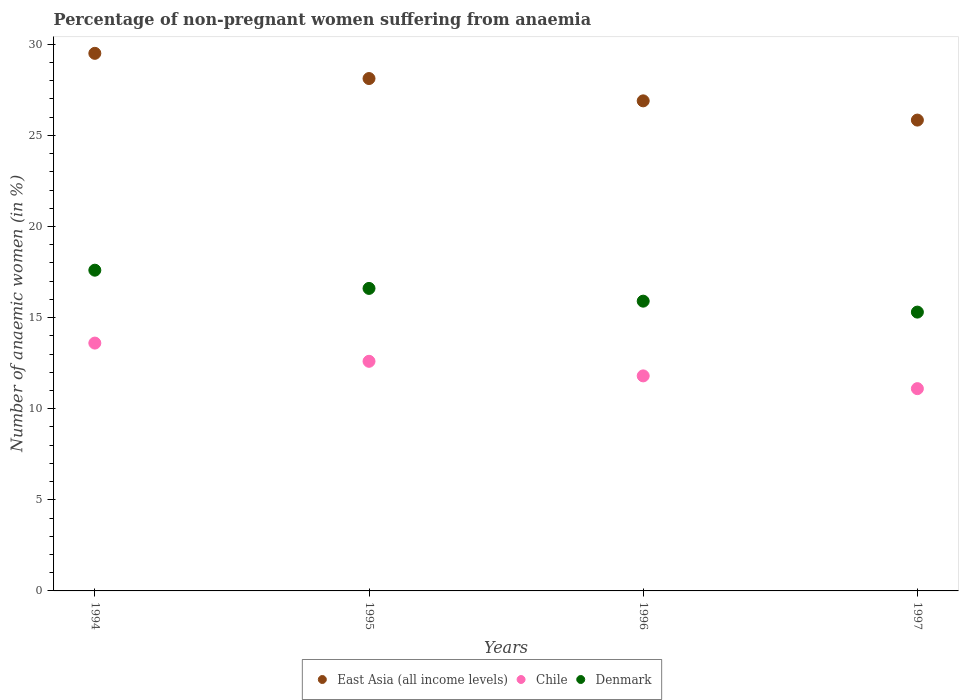How many different coloured dotlines are there?
Offer a very short reply. 3. Is the number of dotlines equal to the number of legend labels?
Ensure brevity in your answer.  Yes. What is the percentage of non-pregnant women suffering from anaemia in East Asia (all income levels) in 1994?
Offer a terse response. 29.5. Across all years, what is the minimum percentage of non-pregnant women suffering from anaemia in Denmark?
Your response must be concise. 15.3. What is the total percentage of non-pregnant women suffering from anaemia in Denmark in the graph?
Make the answer very short. 65.4. What is the difference between the percentage of non-pregnant women suffering from anaemia in East Asia (all income levels) in 1996 and that in 1997?
Keep it short and to the point. 1.06. What is the difference between the percentage of non-pregnant women suffering from anaemia in East Asia (all income levels) in 1994 and the percentage of non-pregnant women suffering from anaemia in Denmark in 1996?
Your response must be concise. 13.6. What is the average percentage of non-pregnant women suffering from anaemia in Denmark per year?
Ensure brevity in your answer.  16.35. In the year 1996, what is the difference between the percentage of non-pregnant women suffering from anaemia in Chile and percentage of non-pregnant women suffering from anaemia in East Asia (all income levels)?
Your answer should be compact. -15.09. In how many years, is the percentage of non-pregnant women suffering from anaemia in East Asia (all income levels) greater than 3 %?
Offer a terse response. 4. What is the ratio of the percentage of non-pregnant women suffering from anaemia in East Asia (all income levels) in 1996 to that in 1997?
Your response must be concise. 1.04. Is the difference between the percentage of non-pregnant women suffering from anaemia in Chile in 1994 and 1995 greater than the difference between the percentage of non-pregnant women suffering from anaemia in East Asia (all income levels) in 1994 and 1995?
Provide a succinct answer. No. Is it the case that in every year, the sum of the percentage of non-pregnant women suffering from anaemia in Denmark and percentage of non-pregnant women suffering from anaemia in Chile  is greater than the percentage of non-pregnant women suffering from anaemia in East Asia (all income levels)?
Keep it short and to the point. Yes. Does the percentage of non-pregnant women suffering from anaemia in Denmark monotonically increase over the years?
Offer a very short reply. No. Is the percentage of non-pregnant women suffering from anaemia in Denmark strictly greater than the percentage of non-pregnant women suffering from anaemia in Chile over the years?
Give a very brief answer. Yes. How many dotlines are there?
Your answer should be very brief. 3. What is the difference between two consecutive major ticks on the Y-axis?
Provide a succinct answer. 5. Does the graph contain grids?
Make the answer very short. No. Where does the legend appear in the graph?
Your answer should be very brief. Bottom center. How are the legend labels stacked?
Your response must be concise. Horizontal. What is the title of the graph?
Provide a short and direct response. Percentage of non-pregnant women suffering from anaemia. What is the label or title of the X-axis?
Keep it short and to the point. Years. What is the label or title of the Y-axis?
Provide a succinct answer. Number of anaemic women (in %). What is the Number of anaemic women (in %) of East Asia (all income levels) in 1994?
Make the answer very short. 29.5. What is the Number of anaemic women (in %) of Chile in 1994?
Give a very brief answer. 13.6. What is the Number of anaemic women (in %) of Denmark in 1994?
Offer a very short reply. 17.6. What is the Number of anaemic women (in %) of East Asia (all income levels) in 1995?
Your response must be concise. 28.12. What is the Number of anaemic women (in %) of Chile in 1995?
Provide a succinct answer. 12.6. What is the Number of anaemic women (in %) in East Asia (all income levels) in 1996?
Provide a succinct answer. 26.89. What is the Number of anaemic women (in %) of Denmark in 1996?
Your answer should be compact. 15.9. What is the Number of anaemic women (in %) in East Asia (all income levels) in 1997?
Provide a succinct answer. 25.84. What is the Number of anaemic women (in %) of Denmark in 1997?
Provide a short and direct response. 15.3. Across all years, what is the maximum Number of anaemic women (in %) of East Asia (all income levels)?
Keep it short and to the point. 29.5. Across all years, what is the maximum Number of anaemic women (in %) in Denmark?
Offer a very short reply. 17.6. Across all years, what is the minimum Number of anaemic women (in %) in East Asia (all income levels)?
Your response must be concise. 25.84. Across all years, what is the minimum Number of anaemic women (in %) in Denmark?
Offer a terse response. 15.3. What is the total Number of anaemic women (in %) in East Asia (all income levels) in the graph?
Your response must be concise. 110.35. What is the total Number of anaemic women (in %) of Chile in the graph?
Keep it short and to the point. 49.1. What is the total Number of anaemic women (in %) in Denmark in the graph?
Offer a terse response. 65.4. What is the difference between the Number of anaemic women (in %) of East Asia (all income levels) in 1994 and that in 1995?
Keep it short and to the point. 1.38. What is the difference between the Number of anaemic women (in %) in Chile in 1994 and that in 1995?
Your answer should be compact. 1. What is the difference between the Number of anaemic women (in %) of East Asia (all income levels) in 1994 and that in 1996?
Provide a succinct answer. 2.61. What is the difference between the Number of anaemic women (in %) in Denmark in 1994 and that in 1996?
Offer a terse response. 1.7. What is the difference between the Number of anaemic women (in %) of East Asia (all income levels) in 1994 and that in 1997?
Make the answer very short. 3.66. What is the difference between the Number of anaemic women (in %) in East Asia (all income levels) in 1995 and that in 1996?
Your response must be concise. 1.22. What is the difference between the Number of anaemic women (in %) in Chile in 1995 and that in 1996?
Provide a short and direct response. 0.8. What is the difference between the Number of anaemic women (in %) of East Asia (all income levels) in 1995 and that in 1997?
Offer a terse response. 2.28. What is the difference between the Number of anaemic women (in %) of East Asia (all income levels) in 1996 and that in 1997?
Give a very brief answer. 1.06. What is the difference between the Number of anaemic women (in %) of Denmark in 1996 and that in 1997?
Provide a short and direct response. 0.6. What is the difference between the Number of anaemic women (in %) in East Asia (all income levels) in 1994 and the Number of anaemic women (in %) in Chile in 1995?
Keep it short and to the point. 16.9. What is the difference between the Number of anaemic women (in %) of East Asia (all income levels) in 1994 and the Number of anaemic women (in %) of Denmark in 1995?
Provide a succinct answer. 12.9. What is the difference between the Number of anaemic women (in %) of Chile in 1994 and the Number of anaemic women (in %) of Denmark in 1995?
Offer a very short reply. -3. What is the difference between the Number of anaemic women (in %) of East Asia (all income levels) in 1994 and the Number of anaemic women (in %) of Chile in 1996?
Offer a terse response. 17.7. What is the difference between the Number of anaemic women (in %) of East Asia (all income levels) in 1994 and the Number of anaemic women (in %) of Denmark in 1996?
Provide a succinct answer. 13.6. What is the difference between the Number of anaemic women (in %) in East Asia (all income levels) in 1994 and the Number of anaemic women (in %) in Chile in 1997?
Offer a very short reply. 18.4. What is the difference between the Number of anaemic women (in %) in East Asia (all income levels) in 1994 and the Number of anaemic women (in %) in Denmark in 1997?
Make the answer very short. 14.2. What is the difference between the Number of anaemic women (in %) in East Asia (all income levels) in 1995 and the Number of anaemic women (in %) in Chile in 1996?
Give a very brief answer. 16.32. What is the difference between the Number of anaemic women (in %) of East Asia (all income levels) in 1995 and the Number of anaemic women (in %) of Denmark in 1996?
Provide a succinct answer. 12.22. What is the difference between the Number of anaemic women (in %) in Chile in 1995 and the Number of anaemic women (in %) in Denmark in 1996?
Offer a terse response. -3.3. What is the difference between the Number of anaemic women (in %) in East Asia (all income levels) in 1995 and the Number of anaemic women (in %) in Chile in 1997?
Your answer should be very brief. 17.02. What is the difference between the Number of anaemic women (in %) in East Asia (all income levels) in 1995 and the Number of anaemic women (in %) in Denmark in 1997?
Offer a terse response. 12.82. What is the difference between the Number of anaemic women (in %) of Chile in 1995 and the Number of anaemic women (in %) of Denmark in 1997?
Ensure brevity in your answer.  -2.7. What is the difference between the Number of anaemic women (in %) of East Asia (all income levels) in 1996 and the Number of anaemic women (in %) of Chile in 1997?
Make the answer very short. 15.79. What is the difference between the Number of anaemic women (in %) in East Asia (all income levels) in 1996 and the Number of anaemic women (in %) in Denmark in 1997?
Provide a succinct answer. 11.59. What is the average Number of anaemic women (in %) in East Asia (all income levels) per year?
Provide a short and direct response. 27.59. What is the average Number of anaemic women (in %) of Chile per year?
Provide a succinct answer. 12.28. What is the average Number of anaemic women (in %) of Denmark per year?
Provide a succinct answer. 16.35. In the year 1994, what is the difference between the Number of anaemic women (in %) in East Asia (all income levels) and Number of anaemic women (in %) in Chile?
Provide a succinct answer. 15.9. In the year 1994, what is the difference between the Number of anaemic women (in %) of East Asia (all income levels) and Number of anaemic women (in %) of Denmark?
Provide a short and direct response. 11.9. In the year 1994, what is the difference between the Number of anaemic women (in %) of Chile and Number of anaemic women (in %) of Denmark?
Ensure brevity in your answer.  -4. In the year 1995, what is the difference between the Number of anaemic women (in %) of East Asia (all income levels) and Number of anaemic women (in %) of Chile?
Make the answer very short. 15.52. In the year 1995, what is the difference between the Number of anaemic women (in %) in East Asia (all income levels) and Number of anaemic women (in %) in Denmark?
Offer a terse response. 11.52. In the year 1995, what is the difference between the Number of anaemic women (in %) of Chile and Number of anaemic women (in %) of Denmark?
Provide a succinct answer. -4. In the year 1996, what is the difference between the Number of anaemic women (in %) of East Asia (all income levels) and Number of anaemic women (in %) of Chile?
Offer a terse response. 15.09. In the year 1996, what is the difference between the Number of anaemic women (in %) of East Asia (all income levels) and Number of anaemic women (in %) of Denmark?
Your answer should be very brief. 10.99. In the year 1996, what is the difference between the Number of anaemic women (in %) in Chile and Number of anaemic women (in %) in Denmark?
Your answer should be very brief. -4.1. In the year 1997, what is the difference between the Number of anaemic women (in %) in East Asia (all income levels) and Number of anaemic women (in %) in Chile?
Ensure brevity in your answer.  14.74. In the year 1997, what is the difference between the Number of anaemic women (in %) in East Asia (all income levels) and Number of anaemic women (in %) in Denmark?
Ensure brevity in your answer.  10.54. In the year 1997, what is the difference between the Number of anaemic women (in %) of Chile and Number of anaemic women (in %) of Denmark?
Make the answer very short. -4.2. What is the ratio of the Number of anaemic women (in %) in East Asia (all income levels) in 1994 to that in 1995?
Offer a terse response. 1.05. What is the ratio of the Number of anaemic women (in %) in Chile in 1994 to that in 1995?
Keep it short and to the point. 1.08. What is the ratio of the Number of anaemic women (in %) of Denmark in 1994 to that in 1995?
Provide a short and direct response. 1.06. What is the ratio of the Number of anaemic women (in %) of East Asia (all income levels) in 1994 to that in 1996?
Provide a short and direct response. 1.1. What is the ratio of the Number of anaemic women (in %) in Chile in 1994 to that in 1996?
Offer a very short reply. 1.15. What is the ratio of the Number of anaemic women (in %) of Denmark in 1994 to that in 1996?
Offer a terse response. 1.11. What is the ratio of the Number of anaemic women (in %) in East Asia (all income levels) in 1994 to that in 1997?
Provide a succinct answer. 1.14. What is the ratio of the Number of anaemic women (in %) in Chile in 1994 to that in 1997?
Your response must be concise. 1.23. What is the ratio of the Number of anaemic women (in %) of Denmark in 1994 to that in 1997?
Give a very brief answer. 1.15. What is the ratio of the Number of anaemic women (in %) of East Asia (all income levels) in 1995 to that in 1996?
Ensure brevity in your answer.  1.05. What is the ratio of the Number of anaemic women (in %) in Chile in 1995 to that in 1996?
Keep it short and to the point. 1.07. What is the ratio of the Number of anaemic women (in %) of Denmark in 1995 to that in 1996?
Offer a very short reply. 1.04. What is the ratio of the Number of anaemic women (in %) in East Asia (all income levels) in 1995 to that in 1997?
Ensure brevity in your answer.  1.09. What is the ratio of the Number of anaemic women (in %) of Chile in 1995 to that in 1997?
Ensure brevity in your answer.  1.14. What is the ratio of the Number of anaemic women (in %) in Denmark in 1995 to that in 1997?
Give a very brief answer. 1.08. What is the ratio of the Number of anaemic women (in %) of East Asia (all income levels) in 1996 to that in 1997?
Your answer should be very brief. 1.04. What is the ratio of the Number of anaemic women (in %) of Chile in 1996 to that in 1997?
Offer a very short reply. 1.06. What is the ratio of the Number of anaemic women (in %) of Denmark in 1996 to that in 1997?
Ensure brevity in your answer.  1.04. What is the difference between the highest and the second highest Number of anaemic women (in %) in East Asia (all income levels)?
Provide a succinct answer. 1.38. What is the difference between the highest and the second highest Number of anaemic women (in %) of Denmark?
Make the answer very short. 1. What is the difference between the highest and the lowest Number of anaemic women (in %) of East Asia (all income levels)?
Ensure brevity in your answer.  3.66. What is the difference between the highest and the lowest Number of anaemic women (in %) of Chile?
Ensure brevity in your answer.  2.5. 